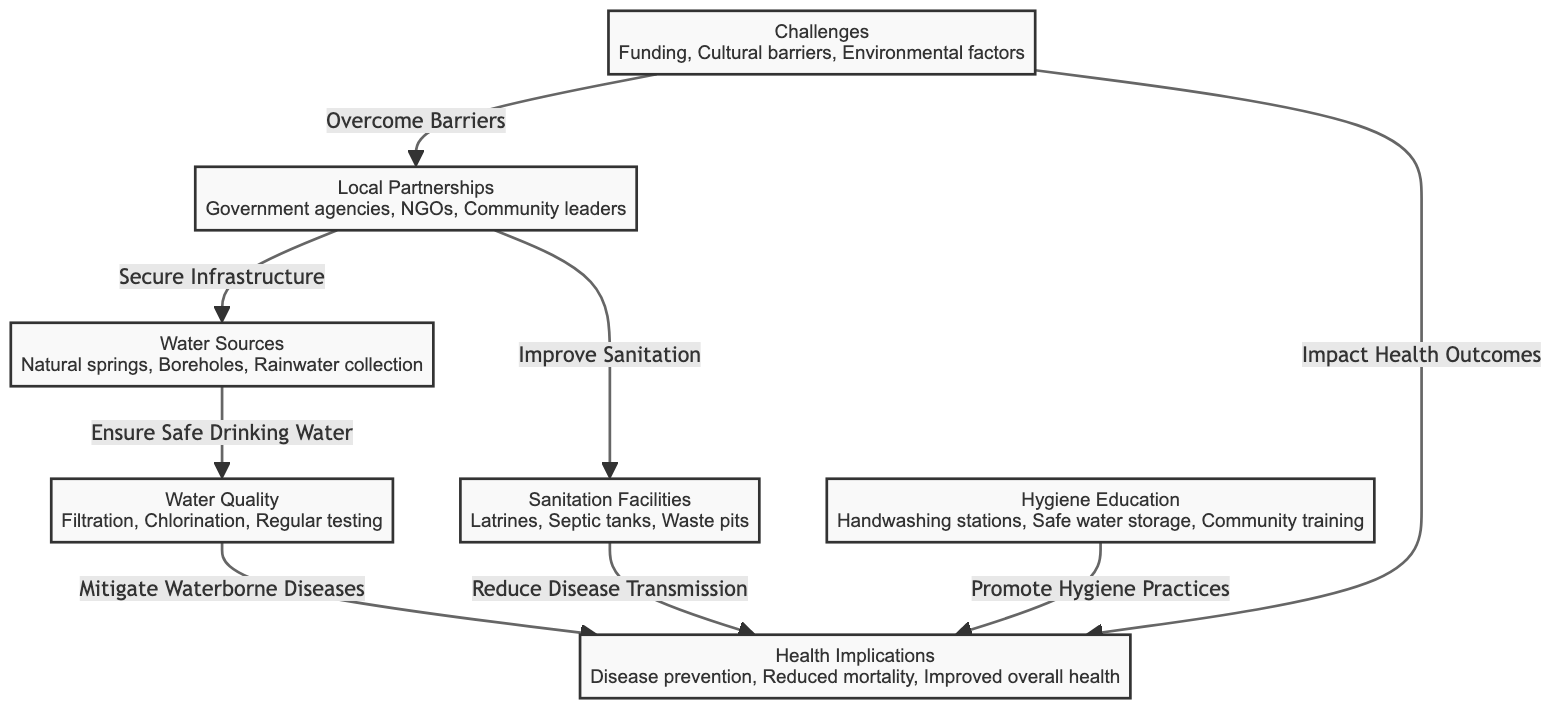What are the main water sources listed in the diagram? The diagram specifies three main water sources: natural springs, boreholes, and rainwater collection. Each of these is outlined clearly under the "Water Sources" node.
Answer: natural springs, Boreholes, Rainwater collection What is the relationship between water quality and health implications? The diagram shows that water quality, which is addressed through filtration, chlorination, and regular testing, ensures safe drinking water, thereby mitigating waterborne diseases, which positively impacts health implications.
Answer: Mitigate Waterborne Diseases How many challenges are identified in the diagram? The diagram presents three challenges: funding, cultural barriers, and environmental factors. Each of these is listed under the "Challenges" node.
Answer: 3 What measures are included under hygiene education? The hygiene education node lists three measures: handwashing stations, safe water storage, and community training. These help promote hygiene practices essential for health.
Answer: Handwashing stations, Safe water storage, Community training How do local partnerships impact sanitation facilities? Local partnerships, represented by collaborations with government agencies, NGOs, and community leaders, are linked to improving sanitation facilities as depicted in the diagram.
Answer: Improve Sanitation What is the flow of information from sanitation facilities to health implications? The diagram indicates a direct relationship where sanitation facilities, such as latrines and septic tanks, reduce disease transmission, which subsequently contributes to health implications such as disease prevention and improved health outcomes.
Answer: Reduce Disease Transmission What impacts do challenges have on health outcomes according to the diagram? The challenges node states that they can impact health outcomes by affecting local partnerships and limiting health improvements within the refugee camps. This means that overcoming these challenges can be crucial for better health implications.
Answer: Impact Health Outcomes Which node is directly linked to securing water sources? According to the diagram, local partnerships have a direct link to securing water sources, underscoring the importance of collaboration with various stakeholders for access to safe water.
Answer: Secure Infrastructure 